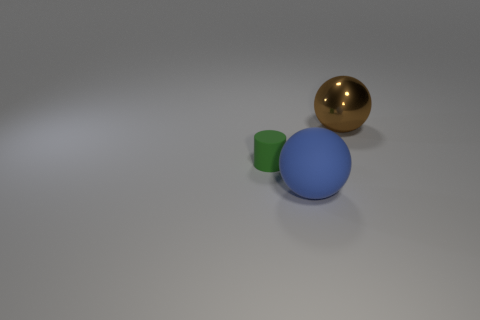What number of things are either spheres behind the tiny green matte cylinder or objects that are in front of the green rubber object? There is one sphere located behind the tiny green matte cylinder, and there are no objects in front of the green matte cylinder, making the total number of such objects one. 